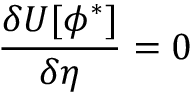<formula> <loc_0><loc_0><loc_500><loc_500>\frac { \delta U [ \phi ^ { * } ] } { \delta \eta } = 0</formula> 